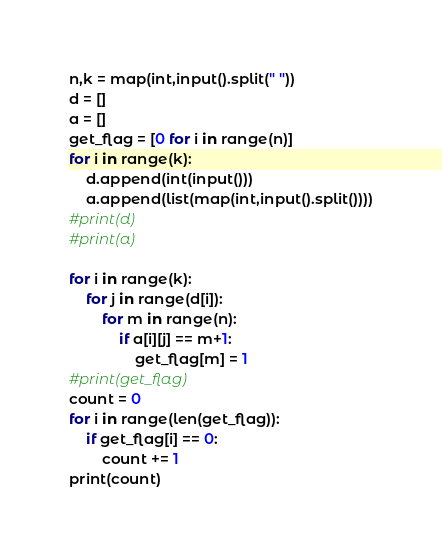<code> <loc_0><loc_0><loc_500><loc_500><_Python_>n,k = map(int,input().split(" "))
d = []
a = []
get_flag = [0 for i in range(n)]
for i in range(k):
    d.append(int(input()))
    a.append(list(map(int,input().split())))
#print(d)
#print(a)

for i in range(k):
    for j in range(d[i]):
        for m in range(n):
            if a[i][j] == m+1:
                get_flag[m] = 1
#print(get_flag)
count = 0
for i in range(len(get_flag)):
    if get_flag[i] == 0:
        count += 1
print(count)</code> 